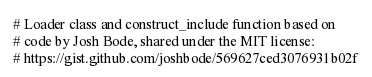Convert code to text. <code><loc_0><loc_0><loc_500><loc_500><_Python_># Loader class and construct_include function based on
# code by Josh Bode, shared under the MIT license:
# https://gist.github.com/joshbode/569627ced3076931b02f
</code> 